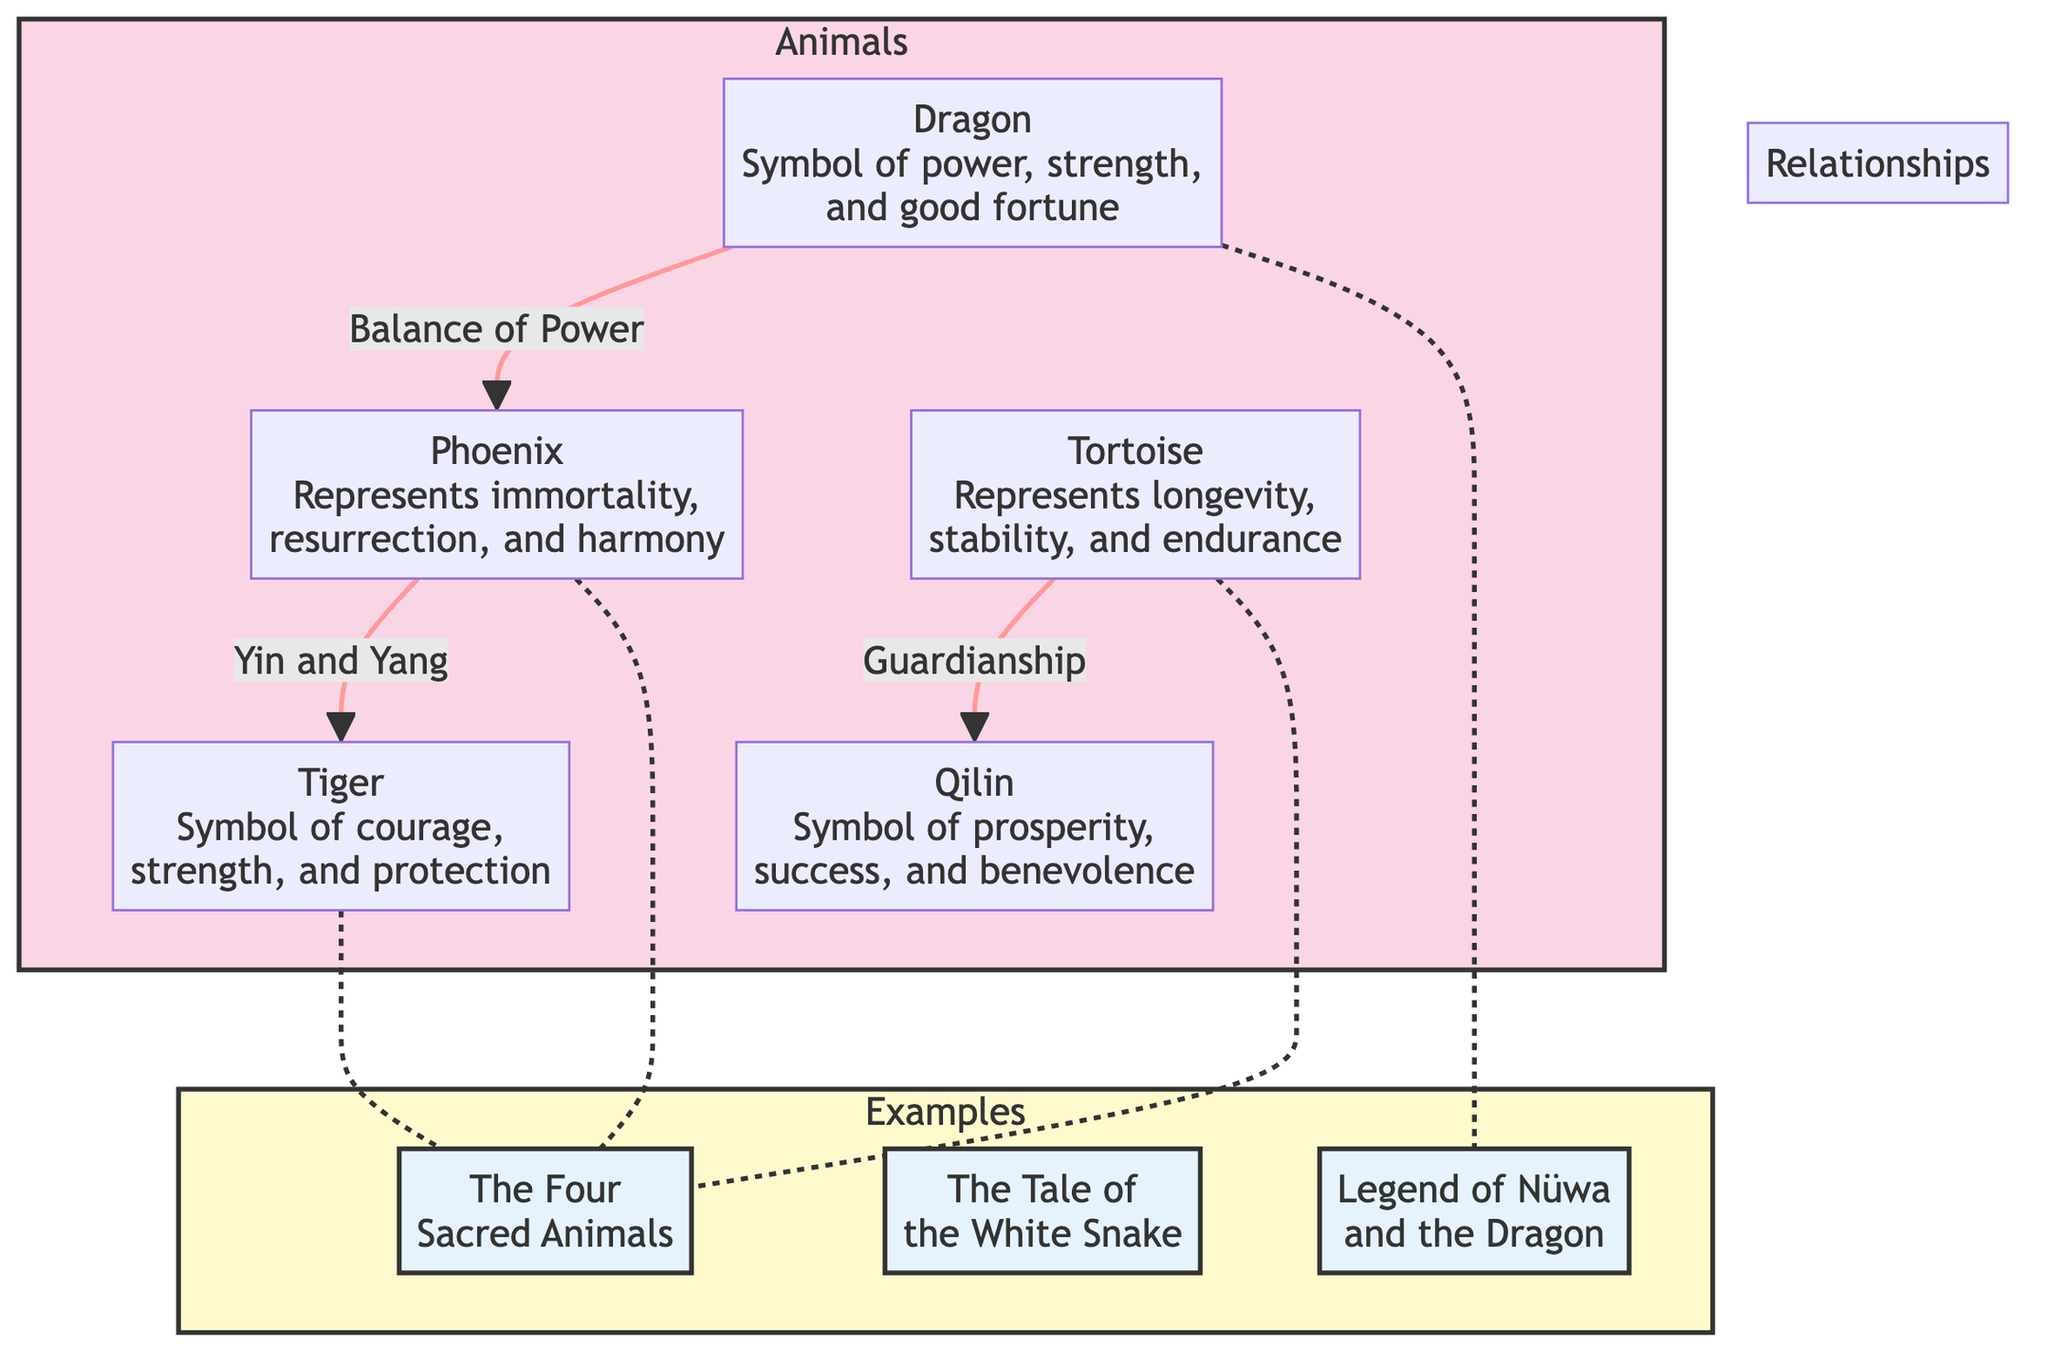What is the symbolism of the Dragon? The Dragon symbolizes power, strength, and good fortune, as indicated in the diagram near the Dragon node.
Answer: power, strength, and good fortune How many animals are represented in the diagram? The diagram lists five animals: Dragon, Phoenix, Tiger, Tortoise, and Qilin. Counting these nodes gives us five animals in total.
Answer: 5 What relationship does Tortoise have with Qilin? The diagram shows that Tortoise represents "Guardianship" towards Qilin. This relationship is explicitly stated in the connections depicted in the diagram.
Answer: Guardianship Which legend is associated with the Dragon? The Legend of Nüwa and the Dragon is the legend specifically linked to the Dragon in the diagram, as indicated by the connection between the Dragon and the legend node.
Answer: Legend of Nüwa and the Dragon What does the Phoenix represent? The Phoenix represents immortality, resurrection, and harmony, which is clearly described next to the Phoenix node.
Answer: immortality, resurrection, and harmony How many relationships are depicted among the animals? There are three distinct relationships depicted: Dragon to Phoenix, Phoenix to Tiger, and Tortoise to Qilin, leading to a total of three relationships shown in the diagram.
Answer: 3 What is the connection between Tiger and the Phoenix? The connection between Tiger and Phoenix is articulated through "Yin and Yang," which is specified in the diagram and highlights their relationship.
Answer: Yin and Yang Which animals are linked to the Four Sacred Animals legend? The Tiger, Phoenix, and Tortoise are all linked to the legend of the Four Sacred Animals as per the connections displayed in the diagram schematic.
Answer: Tiger, Phoenix, Tortoise 